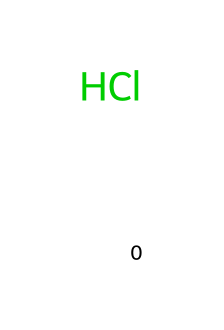What is the chemical symbol for this element? The chemical structure presented is represented by the SMILES notation 'Cl', which corresponds to the chemical symbol for chlorine.
Answer: chlorine How many atoms are present in this chemical? The SMILES notation 'Cl' indicates there is one chlorine atom represented in the structure.
Answer: 1 What type of bond does chlorine commonly form in water treatment? Chlorine typically forms covalent bonds, especially when it combines with other elements in water treatment processes, but it can also form ionic bonds in specific scenarios like when it reacts with metals.
Answer: covalent What is the primary function of chlorine in water treatment? Chlorine is mainly used as a disinfectant to kill bacteria and other pathogens in water treatment systems.
Answer: disinfectant Is chlorine a metal or a non-metal? The element chlorine, represented by the SMILES 'Cl', is classified as a non-metal.
Answer: non-metal What is the oxidation state of chlorine in this form? In its elemental form as indicated by the 'Cl' in the SMILES, chlorine has an oxidation state of 0.
Answer: 0 